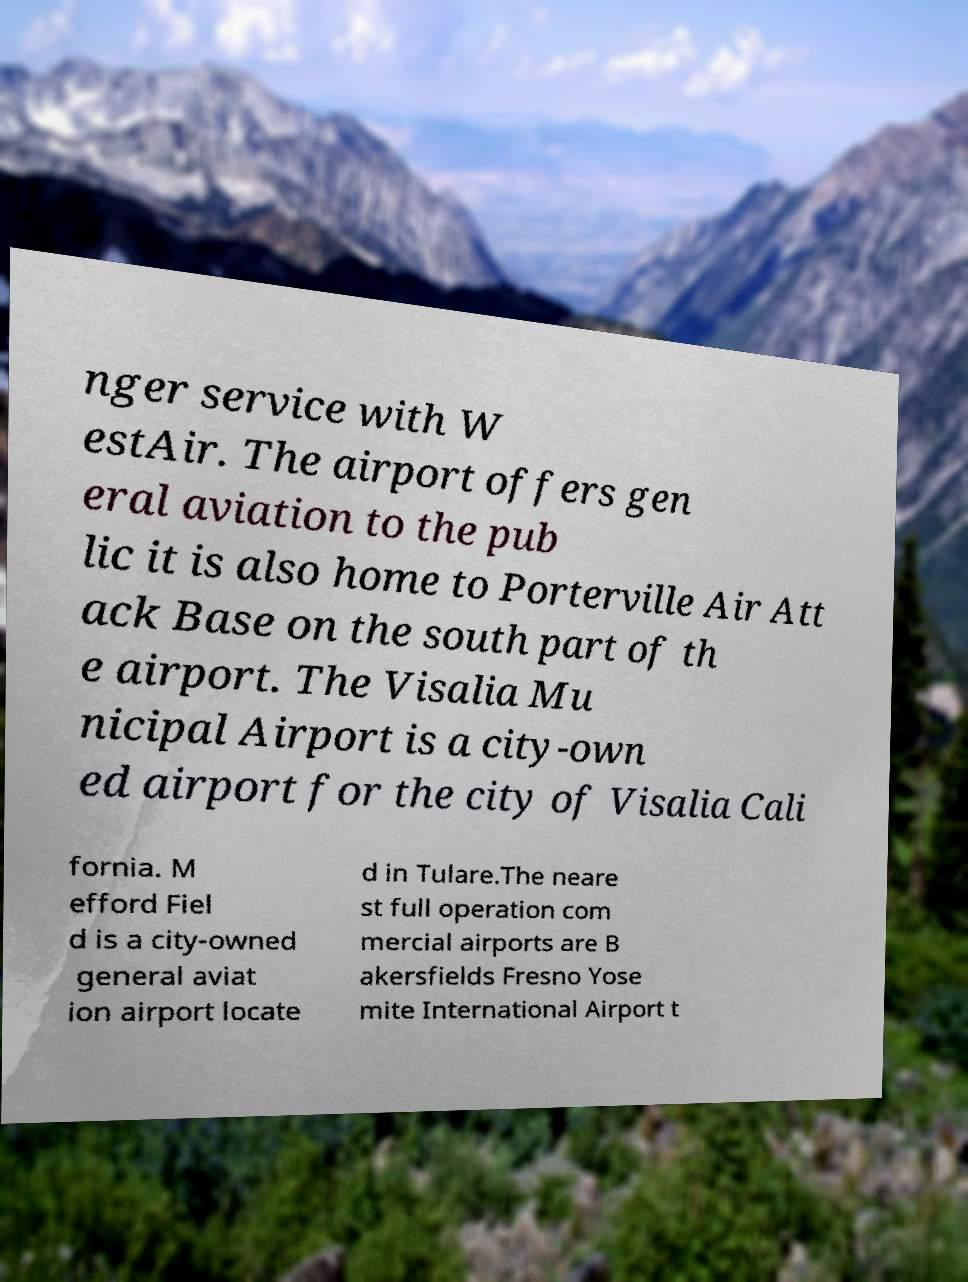There's text embedded in this image that I need extracted. Can you transcribe it verbatim? nger service with W estAir. The airport offers gen eral aviation to the pub lic it is also home to Porterville Air Att ack Base on the south part of th e airport. The Visalia Mu nicipal Airport is a city-own ed airport for the city of Visalia Cali fornia. M efford Fiel d is a city-owned general aviat ion airport locate d in Tulare.The neare st full operation com mercial airports are B akersfields Fresno Yose mite International Airport t 